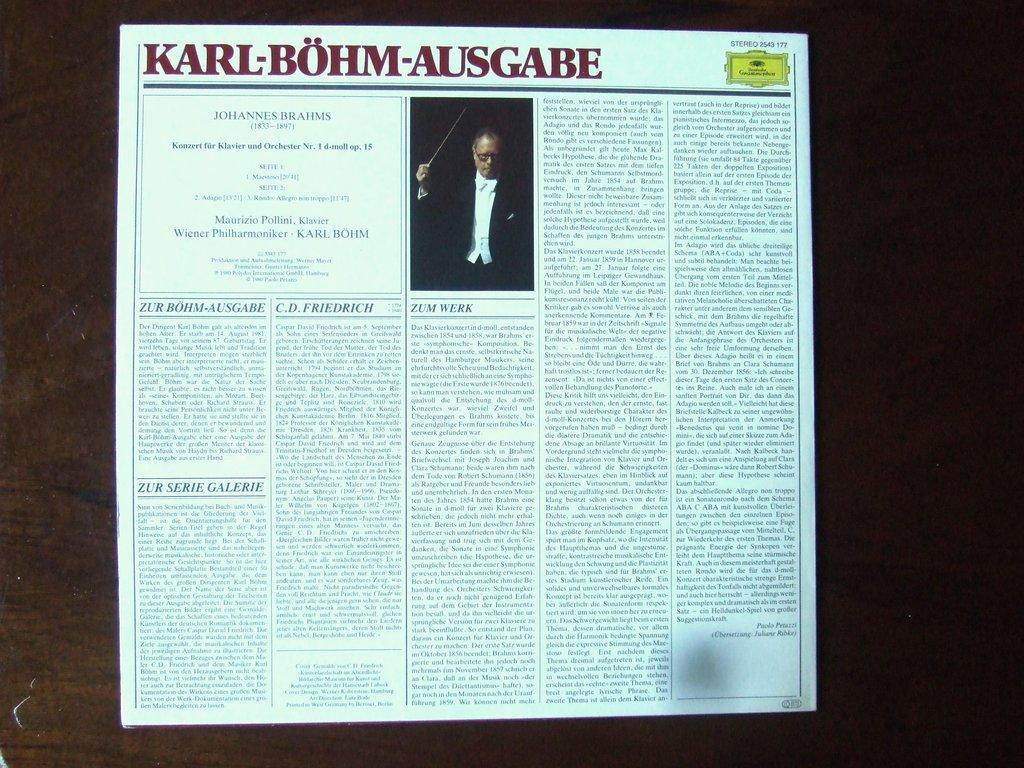<image>
Create a compact narrative representing the image presented. The article shown here is about the man Karl-Bohm-Ausgabe. 